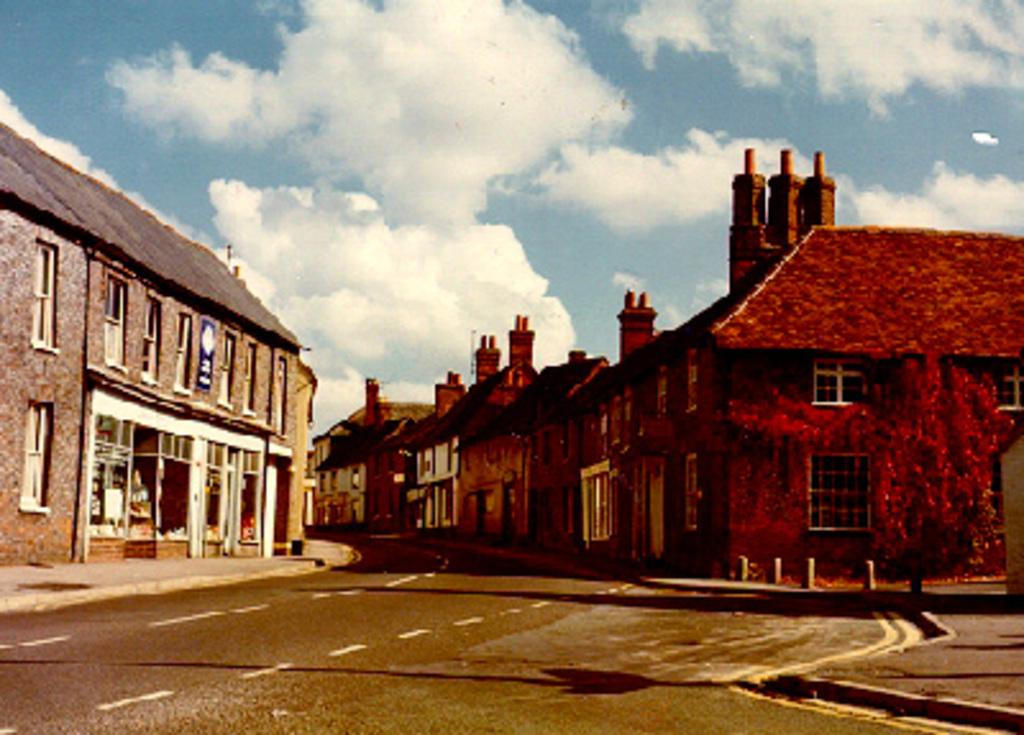What is the main feature of the image? There is a road in the image. What else can be seen in the image besides the road? There are multiple buildings and a tree in the image. How would you describe the sky in the image? The sky is clear in the image, with white clouds visible. Can you see a beggar holding a silver coin on the road in the image? There is no beggar or silver coin present in the image. Is there a boat sailing on the road in the image? There is no boat present in the image, as it is a road and not a body of water. 